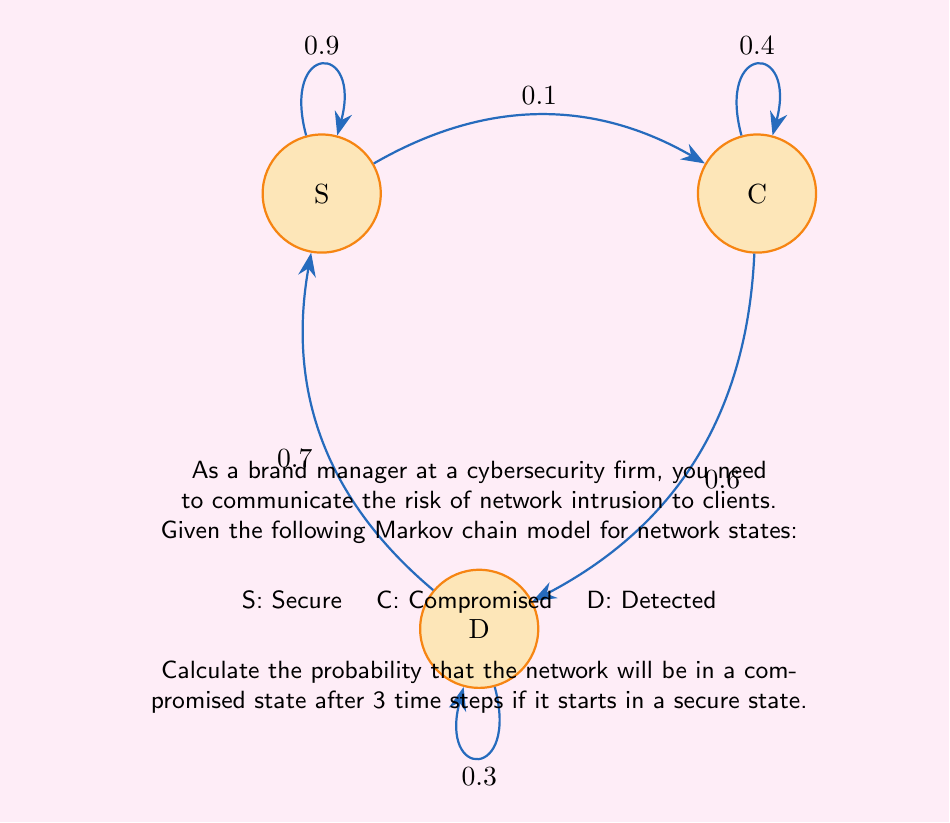Solve this math problem. To solve this problem, we'll use Markov chains and matrix multiplication. Let's follow these steps:

1) First, we need to create the transition matrix P based on the given Markov chain:

   $$P = \begin{bmatrix} 
   0.9 & 0.1 & 0 \\
   0 & 0.4 & 0.6 \\
   0.7 & 0 & 0.3
   \end{bmatrix}$$

   Where the rows and columns represent S, C, and D states respectively.

2) The initial state vector is:

   $$v_0 = \begin{bmatrix} 1 \\ 0 \\ 0 \end{bmatrix}$$

   This represents starting in the secure state.

3) To find the state after 3 time steps, we need to calculate:

   $$v_3 = P^3 \cdot v_0$$

4) Let's calculate $P^3$:

   $$P^2 = \begin{bmatrix} 
   0.81 & 0.13 & 0.06 \\
   0.28 & 0.16 & 0.56 \\
   0.63 & 0.07 & 0.30
   \end{bmatrix}$$

   $$P^3 = \begin{bmatrix} 
   0.747 & 0.133 & 0.120 \\
   0.406 & 0.151 & 0.443 \\
   0.651 & 0.111 & 0.238
   \end{bmatrix}$$

5) Now, we multiply $P^3$ by $v_0$:

   $$v_3 = P^3 \cdot v_0 = \begin{bmatrix} 
   0.747 & 0.133 & 0.120 \\
   0.406 & 0.151 & 0.443 \\
   0.651 & 0.111 & 0.238
   \end{bmatrix} \cdot \begin{bmatrix} 1 \\ 0 \\ 0 \end{bmatrix} = \begin{bmatrix} 0.747 \\ 0.406 \\ 0.651 \end{bmatrix}$$

6) The probability of being in the compromised state after 3 time steps is the second element of this vector.
Answer: 0.406 or approximately 40.6% 